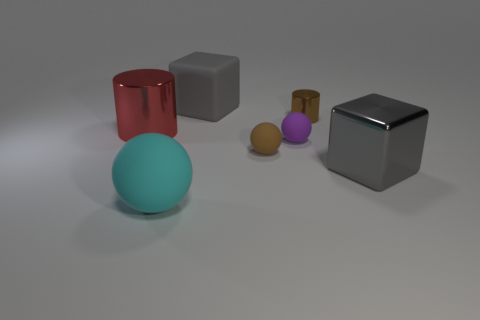What shape is the tiny object that is the same color as the small cylinder?
Give a very brief answer. Sphere. There is a brown thing that is behind the brown thing left of the small cylinder; what is its shape?
Your answer should be compact. Cylinder. The big matte ball has what color?
Offer a terse response. Cyan. How many other objects are the same size as the red thing?
Your response must be concise. 3. What is the big object that is both behind the brown matte ball and in front of the big gray matte object made of?
Keep it short and to the point. Metal. Is the size of the cube that is in front of the red object the same as the big red metallic cylinder?
Give a very brief answer. Yes. Is the color of the big cylinder the same as the big rubber block?
Provide a short and direct response. No. How many things are behind the big gray shiny thing and left of the tiny brown cylinder?
Your answer should be very brief. 4. How many gray objects are right of the cube behind the metal cylinder on the right side of the large cyan ball?
Your answer should be compact. 1. There is another block that is the same color as the metallic block; what size is it?
Your answer should be compact. Large. 